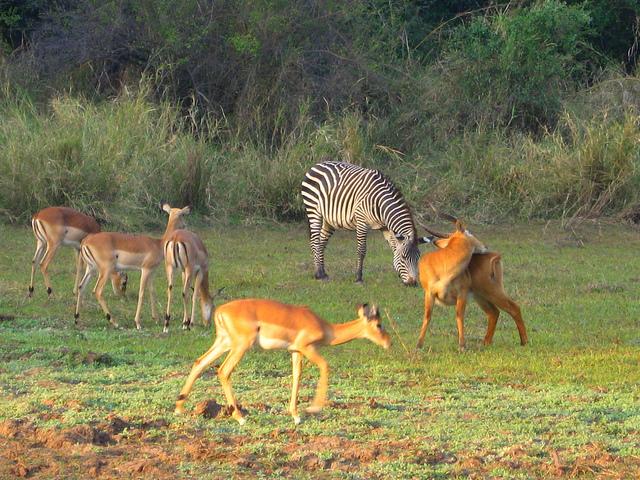How many types of animals are visible?
Concise answer only. 2. Where are the deer?
Answer briefly. In field. What is the majority of animal shown in the picture?
Concise answer only. Deer. 